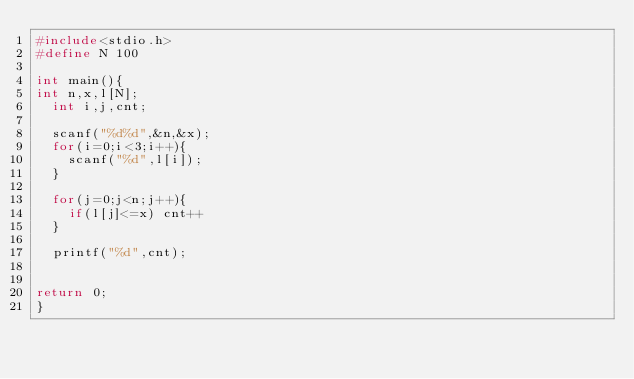Convert code to text. <code><loc_0><loc_0><loc_500><loc_500><_C_>#include<stdio.h>
#define N 100

int main(){
int n,x,l[N];
  int i,j,cnt;
  
  scanf("%d%d",&n,&x);
  for(i=0;i<3;i++){
    scanf("%d",l[i]);
  }
  
  for(j=0;j<n;j++){
    if(l[j]<=x) cnt++
  }
  
  printf("%d",cnt);


return 0;
}</code> 